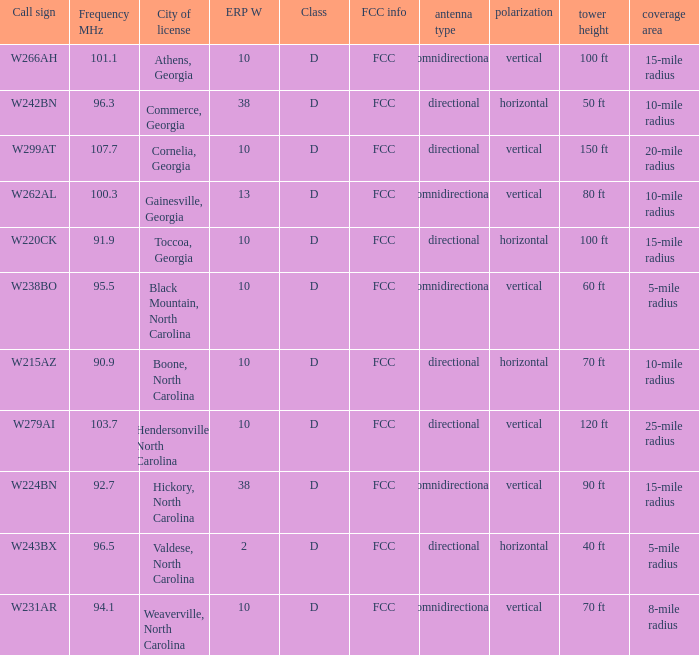What city has larger than 94.1 as a frequency? Athens, Georgia, Commerce, Georgia, Cornelia, Georgia, Gainesville, Georgia, Black Mountain, North Carolina, Hendersonville, North Carolina, Valdese, North Carolina. 